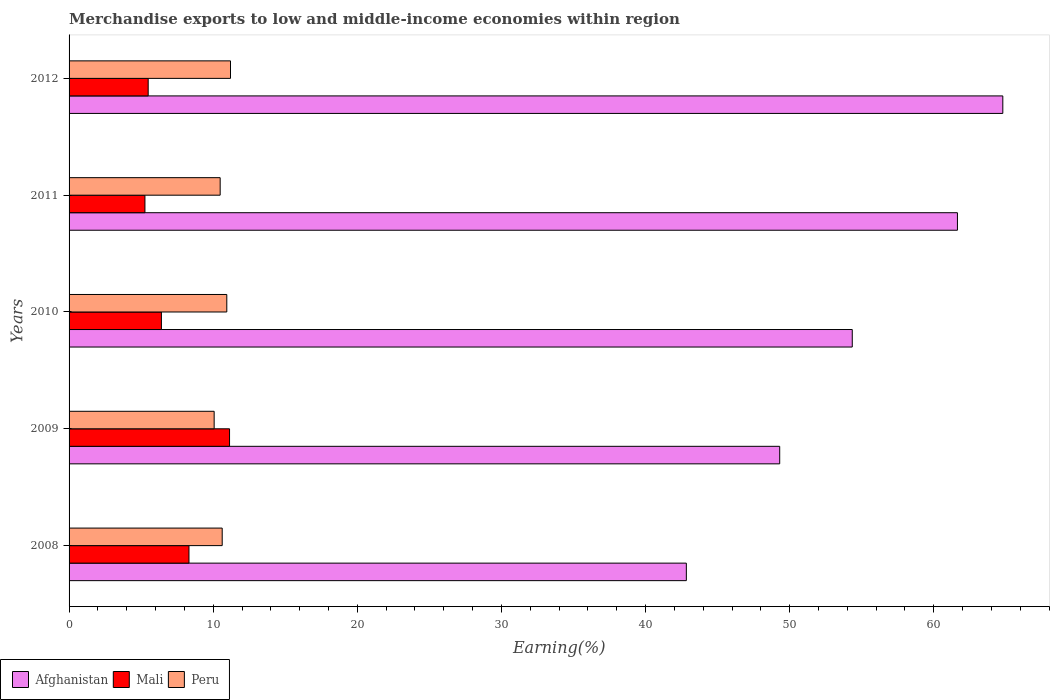Are the number of bars on each tick of the Y-axis equal?
Keep it short and to the point. Yes. How many bars are there on the 3rd tick from the top?
Your response must be concise. 3. What is the label of the 2nd group of bars from the top?
Your answer should be very brief. 2011. What is the percentage of amount earned from merchandise exports in Mali in 2009?
Provide a succinct answer. 11.14. Across all years, what is the maximum percentage of amount earned from merchandise exports in Afghanistan?
Offer a terse response. 64.79. Across all years, what is the minimum percentage of amount earned from merchandise exports in Mali?
Keep it short and to the point. 5.26. What is the total percentage of amount earned from merchandise exports in Peru in the graph?
Give a very brief answer. 53.32. What is the difference between the percentage of amount earned from merchandise exports in Mali in 2010 and that in 2012?
Give a very brief answer. 0.92. What is the difference between the percentage of amount earned from merchandise exports in Mali in 2011 and the percentage of amount earned from merchandise exports in Peru in 2012?
Offer a very short reply. -5.94. What is the average percentage of amount earned from merchandise exports in Afghanistan per year?
Provide a succinct answer. 54.58. In the year 2012, what is the difference between the percentage of amount earned from merchandise exports in Afghanistan and percentage of amount earned from merchandise exports in Peru?
Provide a succinct answer. 53.59. What is the ratio of the percentage of amount earned from merchandise exports in Mali in 2009 to that in 2010?
Your answer should be compact. 1.74. What is the difference between the highest and the second highest percentage of amount earned from merchandise exports in Peru?
Provide a short and direct response. 0.26. What is the difference between the highest and the lowest percentage of amount earned from merchandise exports in Mali?
Make the answer very short. 5.87. What does the 1st bar from the top in 2009 represents?
Your answer should be compact. Peru. What does the 2nd bar from the bottom in 2011 represents?
Give a very brief answer. Mali. Are all the bars in the graph horizontal?
Your answer should be very brief. Yes. How many years are there in the graph?
Provide a succinct answer. 5. What is the difference between two consecutive major ticks on the X-axis?
Your response must be concise. 10. Does the graph contain any zero values?
Make the answer very short. No. Does the graph contain grids?
Give a very brief answer. No. Where does the legend appear in the graph?
Offer a terse response. Bottom left. How many legend labels are there?
Keep it short and to the point. 3. What is the title of the graph?
Offer a very short reply. Merchandise exports to low and middle-income economies within region. Does "Sweden" appear as one of the legend labels in the graph?
Ensure brevity in your answer.  No. What is the label or title of the X-axis?
Offer a terse response. Earning(%). What is the label or title of the Y-axis?
Provide a short and direct response. Years. What is the Earning(%) in Afghanistan in 2008?
Keep it short and to the point. 42.83. What is the Earning(%) in Mali in 2008?
Give a very brief answer. 8.32. What is the Earning(%) in Peru in 2008?
Your answer should be compact. 10.63. What is the Earning(%) in Afghanistan in 2009?
Your answer should be very brief. 49.31. What is the Earning(%) in Mali in 2009?
Provide a succinct answer. 11.14. What is the Earning(%) in Peru in 2009?
Make the answer very short. 10.07. What is the Earning(%) of Afghanistan in 2010?
Make the answer very short. 54.35. What is the Earning(%) of Mali in 2010?
Your answer should be very brief. 6.41. What is the Earning(%) in Peru in 2010?
Offer a terse response. 10.94. What is the Earning(%) of Afghanistan in 2011?
Provide a succinct answer. 61.64. What is the Earning(%) of Mali in 2011?
Make the answer very short. 5.26. What is the Earning(%) in Peru in 2011?
Ensure brevity in your answer.  10.48. What is the Earning(%) of Afghanistan in 2012?
Provide a succinct answer. 64.79. What is the Earning(%) of Mali in 2012?
Ensure brevity in your answer.  5.49. What is the Earning(%) of Peru in 2012?
Make the answer very short. 11.2. Across all years, what is the maximum Earning(%) in Afghanistan?
Keep it short and to the point. 64.79. Across all years, what is the maximum Earning(%) of Mali?
Your answer should be very brief. 11.14. Across all years, what is the maximum Earning(%) in Peru?
Your response must be concise. 11.2. Across all years, what is the minimum Earning(%) of Afghanistan?
Provide a succinct answer. 42.83. Across all years, what is the minimum Earning(%) in Mali?
Keep it short and to the point. 5.26. Across all years, what is the minimum Earning(%) in Peru?
Ensure brevity in your answer.  10.07. What is the total Earning(%) of Afghanistan in the graph?
Offer a terse response. 272.92. What is the total Earning(%) of Mali in the graph?
Your answer should be compact. 36.62. What is the total Earning(%) of Peru in the graph?
Give a very brief answer. 53.32. What is the difference between the Earning(%) of Afghanistan in 2008 and that in 2009?
Offer a very short reply. -6.48. What is the difference between the Earning(%) in Mali in 2008 and that in 2009?
Provide a succinct answer. -2.82. What is the difference between the Earning(%) of Peru in 2008 and that in 2009?
Make the answer very short. 0.56. What is the difference between the Earning(%) of Afghanistan in 2008 and that in 2010?
Offer a terse response. -11.51. What is the difference between the Earning(%) in Mali in 2008 and that in 2010?
Offer a very short reply. 1.91. What is the difference between the Earning(%) of Peru in 2008 and that in 2010?
Ensure brevity in your answer.  -0.32. What is the difference between the Earning(%) in Afghanistan in 2008 and that in 2011?
Your response must be concise. -18.81. What is the difference between the Earning(%) in Mali in 2008 and that in 2011?
Offer a terse response. 3.06. What is the difference between the Earning(%) of Peru in 2008 and that in 2011?
Your answer should be compact. 0.14. What is the difference between the Earning(%) in Afghanistan in 2008 and that in 2012?
Give a very brief answer. -21.96. What is the difference between the Earning(%) of Mali in 2008 and that in 2012?
Your response must be concise. 2.83. What is the difference between the Earning(%) of Peru in 2008 and that in 2012?
Your response must be concise. -0.58. What is the difference between the Earning(%) in Afghanistan in 2009 and that in 2010?
Give a very brief answer. -5.04. What is the difference between the Earning(%) in Mali in 2009 and that in 2010?
Your answer should be very brief. 4.73. What is the difference between the Earning(%) in Peru in 2009 and that in 2010?
Make the answer very short. -0.88. What is the difference between the Earning(%) of Afghanistan in 2009 and that in 2011?
Provide a succinct answer. -12.33. What is the difference between the Earning(%) in Mali in 2009 and that in 2011?
Offer a terse response. 5.87. What is the difference between the Earning(%) of Peru in 2009 and that in 2011?
Offer a very short reply. -0.42. What is the difference between the Earning(%) in Afghanistan in 2009 and that in 2012?
Ensure brevity in your answer.  -15.48. What is the difference between the Earning(%) in Mali in 2009 and that in 2012?
Offer a terse response. 5.65. What is the difference between the Earning(%) of Peru in 2009 and that in 2012?
Your answer should be compact. -1.13. What is the difference between the Earning(%) in Afghanistan in 2010 and that in 2011?
Make the answer very short. -7.3. What is the difference between the Earning(%) of Mali in 2010 and that in 2011?
Offer a terse response. 1.14. What is the difference between the Earning(%) of Peru in 2010 and that in 2011?
Ensure brevity in your answer.  0.46. What is the difference between the Earning(%) in Afghanistan in 2010 and that in 2012?
Offer a very short reply. -10.45. What is the difference between the Earning(%) in Mali in 2010 and that in 2012?
Ensure brevity in your answer.  0.92. What is the difference between the Earning(%) in Peru in 2010 and that in 2012?
Provide a succinct answer. -0.26. What is the difference between the Earning(%) in Afghanistan in 2011 and that in 2012?
Your answer should be compact. -3.15. What is the difference between the Earning(%) of Mali in 2011 and that in 2012?
Offer a terse response. -0.22. What is the difference between the Earning(%) of Peru in 2011 and that in 2012?
Offer a terse response. -0.72. What is the difference between the Earning(%) in Afghanistan in 2008 and the Earning(%) in Mali in 2009?
Your response must be concise. 31.7. What is the difference between the Earning(%) in Afghanistan in 2008 and the Earning(%) in Peru in 2009?
Your answer should be very brief. 32.77. What is the difference between the Earning(%) in Mali in 2008 and the Earning(%) in Peru in 2009?
Offer a very short reply. -1.75. What is the difference between the Earning(%) in Afghanistan in 2008 and the Earning(%) in Mali in 2010?
Your answer should be compact. 36.42. What is the difference between the Earning(%) in Afghanistan in 2008 and the Earning(%) in Peru in 2010?
Your answer should be compact. 31.89. What is the difference between the Earning(%) in Mali in 2008 and the Earning(%) in Peru in 2010?
Your answer should be compact. -2.62. What is the difference between the Earning(%) in Afghanistan in 2008 and the Earning(%) in Mali in 2011?
Make the answer very short. 37.57. What is the difference between the Earning(%) in Afghanistan in 2008 and the Earning(%) in Peru in 2011?
Make the answer very short. 32.35. What is the difference between the Earning(%) of Mali in 2008 and the Earning(%) of Peru in 2011?
Your response must be concise. -2.17. What is the difference between the Earning(%) of Afghanistan in 2008 and the Earning(%) of Mali in 2012?
Provide a succinct answer. 37.34. What is the difference between the Earning(%) in Afghanistan in 2008 and the Earning(%) in Peru in 2012?
Keep it short and to the point. 31.63. What is the difference between the Earning(%) in Mali in 2008 and the Earning(%) in Peru in 2012?
Make the answer very short. -2.88. What is the difference between the Earning(%) of Afghanistan in 2009 and the Earning(%) of Mali in 2010?
Your response must be concise. 42.9. What is the difference between the Earning(%) in Afghanistan in 2009 and the Earning(%) in Peru in 2010?
Provide a succinct answer. 38.37. What is the difference between the Earning(%) of Mali in 2009 and the Earning(%) of Peru in 2010?
Provide a succinct answer. 0.19. What is the difference between the Earning(%) of Afghanistan in 2009 and the Earning(%) of Mali in 2011?
Your answer should be compact. 44.05. What is the difference between the Earning(%) of Afghanistan in 2009 and the Earning(%) of Peru in 2011?
Offer a terse response. 38.83. What is the difference between the Earning(%) of Mali in 2009 and the Earning(%) of Peru in 2011?
Offer a very short reply. 0.65. What is the difference between the Earning(%) in Afghanistan in 2009 and the Earning(%) in Mali in 2012?
Keep it short and to the point. 43.82. What is the difference between the Earning(%) in Afghanistan in 2009 and the Earning(%) in Peru in 2012?
Offer a very short reply. 38.11. What is the difference between the Earning(%) in Mali in 2009 and the Earning(%) in Peru in 2012?
Provide a succinct answer. -0.07. What is the difference between the Earning(%) in Afghanistan in 2010 and the Earning(%) in Mali in 2011?
Ensure brevity in your answer.  49.08. What is the difference between the Earning(%) in Afghanistan in 2010 and the Earning(%) in Peru in 2011?
Provide a short and direct response. 43.86. What is the difference between the Earning(%) of Mali in 2010 and the Earning(%) of Peru in 2011?
Your answer should be compact. -4.08. What is the difference between the Earning(%) of Afghanistan in 2010 and the Earning(%) of Mali in 2012?
Offer a very short reply. 48.86. What is the difference between the Earning(%) in Afghanistan in 2010 and the Earning(%) in Peru in 2012?
Give a very brief answer. 43.14. What is the difference between the Earning(%) of Mali in 2010 and the Earning(%) of Peru in 2012?
Your answer should be compact. -4.79. What is the difference between the Earning(%) in Afghanistan in 2011 and the Earning(%) in Mali in 2012?
Make the answer very short. 56.15. What is the difference between the Earning(%) in Afghanistan in 2011 and the Earning(%) in Peru in 2012?
Give a very brief answer. 50.44. What is the difference between the Earning(%) of Mali in 2011 and the Earning(%) of Peru in 2012?
Offer a terse response. -5.94. What is the average Earning(%) of Afghanistan per year?
Ensure brevity in your answer.  54.58. What is the average Earning(%) in Mali per year?
Your answer should be very brief. 7.32. What is the average Earning(%) of Peru per year?
Keep it short and to the point. 10.66. In the year 2008, what is the difference between the Earning(%) in Afghanistan and Earning(%) in Mali?
Offer a terse response. 34.51. In the year 2008, what is the difference between the Earning(%) in Afghanistan and Earning(%) in Peru?
Give a very brief answer. 32.21. In the year 2008, what is the difference between the Earning(%) of Mali and Earning(%) of Peru?
Your answer should be very brief. -2.31. In the year 2009, what is the difference between the Earning(%) of Afghanistan and Earning(%) of Mali?
Provide a short and direct response. 38.17. In the year 2009, what is the difference between the Earning(%) in Afghanistan and Earning(%) in Peru?
Keep it short and to the point. 39.24. In the year 2009, what is the difference between the Earning(%) in Mali and Earning(%) in Peru?
Give a very brief answer. 1.07. In the year 2010, what is the difference between the Earning(%) of Afghanistan and Earning(%) of Mali?
Ensure brevity in your answer.  47.94. In the year 2010, what is the difference between the Earning(%) of Afghanistan and Earning(%) of Peru?
Your answer should be very brief. 43.4. In the year 2010, what is the difference between the Earning(%) of Mali and Earning(%) of Peru?
Provide a succinct answer. -4.54. In the year 2011, what is the difference between the Earning(%) in Afghanistan and Earning(%) in Mali?
Keep it short and to the point. 56.38. In the year 2011, what is the difference between the Earning(%) in Afghanistan and Earning(%) in Peru?
Make the answer very short. 51.16. In the year 2011, what is the difference between the Earning(%) of Mali and Earning(%) of Peru?
Offer a terse response. -5.22. In the year 2012, what is the difference between the Earning(%) in Afghanistan and Earning(%) in Mali?
Provide a succinct answer. 59.3. In the year 2012, what is the difference between the Earning(%) of Afghanistan and Earning(%) of Peru?
Provide a succinct answer. 53.59. In the year 2012, what is the difference between the Earning(%) in Mali and Earning(%) in Peru?
Ensure brevity in your answer.  -5.71. What is the ratio of the Earning(%) of Afghanistan in 2008 to that in 2009?
Your response must be concise. 0.87. What is the ratio of the Earning(%) in Mali in 2008 to that in 2009?
Offer a terse response. 0.75. What is the ratio of the Earning(%) in Peru in 2008 to that in 2009?
Keep it short and to the point. 1.06. What is the ratio of the Earning(%) in Afghanistan in 2008 to that in 2010?
Give a very brief answer. 0.79. What is the ratio of the Earning(%) in Mali in 2008 to that in 2010?
Offer a terse response. 1.3. What is the ratio of the Earning(%) of Peru in 2008 to that in 2010?
Your answer should be very brief. 0.97. What is the ratio of the Earning(%) in Afghanistan in 2008 to that in 2011?
Provide a succinct answer. 0.69. What is the ratio of the Earning(%) of Mali in 2008 to that in 2011?
Keep it short and to the point. 1.58. What is the ratio of the Earning(%) of Peru in 2008 to that in 2011?
Offer a terse response. 1.01. What is the ratio of the Earning(%) of Afghanistan in 2008 to that in 2012?
Make the answer very short. 0.66. What is the ratio of the Earning(%) in Mali in 2008 to that in 2012?
Your answer should be compact. 1.52. What is the ratio of the Earning(%) in Peru in 2008 to that in 2012?
Give a very brief answer. 0.95. What is the ratio of the Earning(%) of Afghanistan in 2009 to that in 2010?
Provide a succinct answer. 0.91. What is the ratio of the Earning(%) in Mali in 2009 to that in 2010?
Your answer should be compact. 1.74. What is the ratio of the Earning(%) in Peru in 2009 to that in 2010?
Offer a very short reply. 0.92. What is the ratio of the Earning(%) of Afghanistan in 2009 to that in 2011?
Provide a succinct answer. 0.8. What is the ratio of the Earning(%) of Mali in 2009 to that in 2011?
Ensure brevity in your answer.  2.12. What is the ratio of the Earning(%) of Peru in 2009 to that in 2011?
Your answer should be compact. 0.96. What is the ratio of the Earning(%) of Afghanistan in 2009 to that in 2012?
Provide a succinct answer. 0.76. What is the ratio of the Earning(%) of Mali in 2009 to that in 2012?
Keep it short and to the point. 2.03. What is the ratio of the Earning(%) of Peru in 2009 to that in 2012?
Offer a terse response. 0.9. What is the ratio of the Earning(%) of Afghanistan in 2010 to that in 2011?
Offer a very short reply. 0.88. What is the ratio of the Earning(%) in Mali in 2010 to that in 2011?
Make the answer very short. 1.22. What is the ratio of the Earning(%) in Peru in 2010 to that in 2011?
Offer a terse response. 1.04. What is the ratio of the Earning(%) in Afghanistan in 2010 to that in 2012?
Offer a terse response. 0.84. What is the ratio of the Earning(%) of Mali in 2010 to that in 2012?
Your answer should be very brief. 1.17. What is the ratio of the Earning(%) of Peru in 2010 to that in 2012?
Provide a short and direct response. 0.98. What is the ratio of the Earning(%) of Afghanistan in 2011 to that in 2012?
Offer a terse response. 0.95. What is the ratio of the Earning(%) of Mali in 2011 to that in 2012?
Ensure brevity in your answer.  0.96. What is the ratio of the Earning(%) in Peru in 2011 to that in 2012?
Ensure brevity in your answer.  0.94. What is the difference between the highest and the second highest Earning(%) in Afghanistan?
Offer a terse response. 3.15. What is the difference between the highest and the second highest Earning(%) of Mali?
Make the answer very short. 2.82. What is the difference between the highest and the second highest Earning(%) of Peru?
Offer a very short reply. 0.26. What is the difference between the highest and the lowest Earning(%) in Afghanistan?
Keep it short and to the point. 21.96. What is the difference between the highest and the lowest Earning(%) of Mali?
Your response must be concise. 5.87. What is the difference between the highest and the lowest Earning(%) in Peru?
Ensure brevity in your answer.  1.13. 